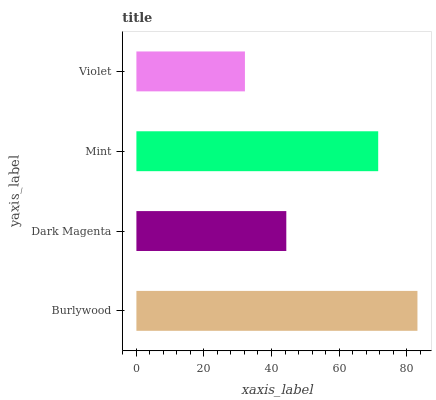Is Violet the minimum?
Answer yes or no. Yes. Is Burlywood the maximum?
Answer yes or no. Yes. Is Dark Magenta the minimum?
Answer yes or no. No. Is Dark Magenta the maximum?
Answer yes or no. No. Is Burlywood greater than Dark Magenta?
Answer yes or no. Yes. Is Dark Magenta less than Burlywood?
Answer yes or no. Yes. Is Dark Magenta greater than Burlywood?
Answer yes or no. No. Is Burlywood less than Dark Magenta?
Answer yes or no. No. Is Mint the high median?
Answer yes or no. Yes. Is Dark Magenta the low median?
Answer yes or no. Yes. Is Dark Magenta the high median?
Answer yes or no. No. Is Burlywood the low median?
Answer yes or no. No. 